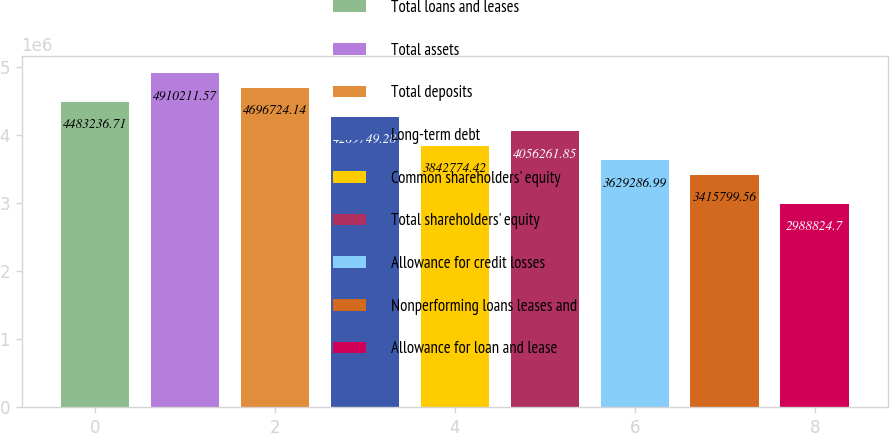Convert chart to OTSL. <chart><loc_0><loc_0><loc_500><loc_500><bar_chart><fcel>Total loans and leases<fcel>Total assets<fcel>Total deposits<fcel>Long-term debt<fcel>Common shareholders' equity<fcel>Total shareholders' equity<fcel>Allowance for credit losses<fcel>Nonperforming loans leases and<fcel>Allowance for loan and lease<nl><fcel>4.48324e+06<fcel>4.91021e+06<fcel>4.69672e+06<fcel>4.26975e+06<fcel>3.84277e+06<fcel>4.05626e+06<fcel>3.62929e+06<fcel>3.4158e+06<fcel>2.98882e+06<nl></chart> 